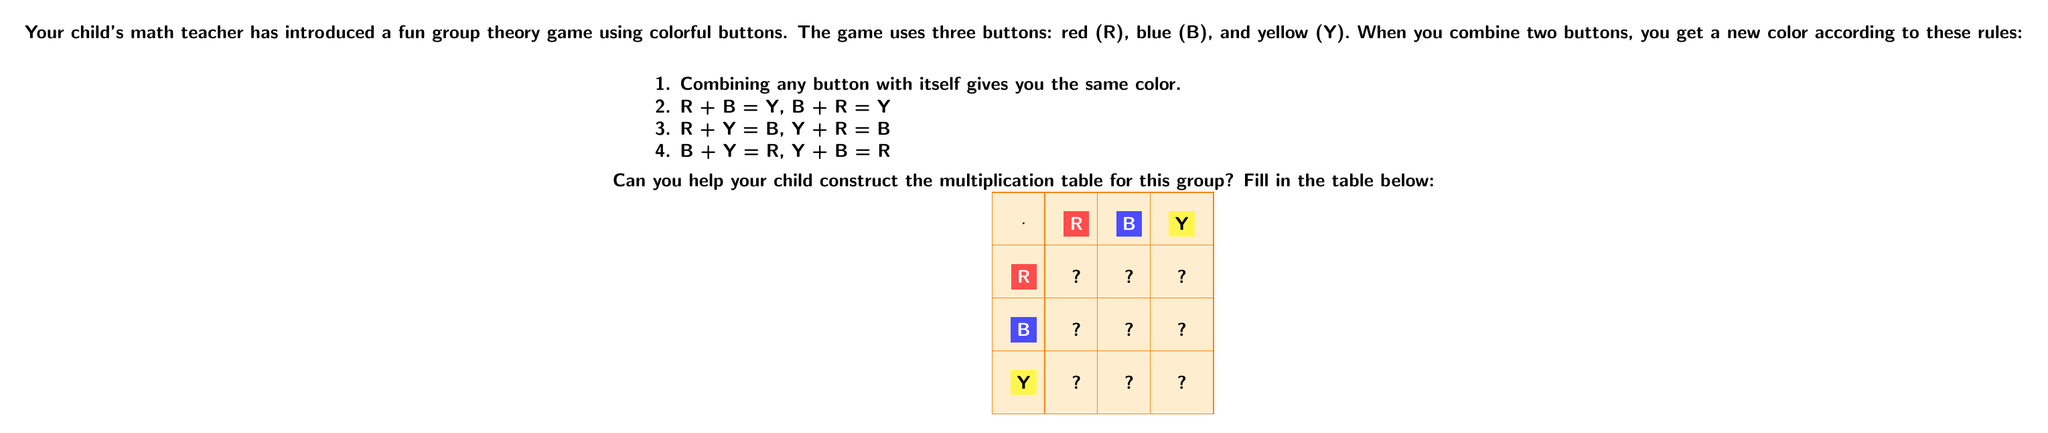Could you help me with this problem? Let's fill in the multiplication table step by step, using the given rules:

1. For the diagonal (combining a color with itself):
   R · R = R
   B · B = B
   Y · Y = Y

2. For R · B and B · R:
   R · B = B · R = Y

3. For R · Y and Y · R:
   R · Y = Y · R = B

4. For B · Y and Y · B:
   B · Y = Y · B = R

Now, let's fill in the table:

[asy]
unitsize(1cm);

string[] labels = {"R", "B", "Y"};
pen[] colors = {red, blue, yellow};
string[][] results = {{"R", "Y", "B"}, {"Y", "B", "R"}, {"B", "R", "Y"}};

for(int i = 0; i < 4; ++i) {
  for(int j = 0; j < 4; ++j) {
    filldraw(box((i,j), (i+1,j+1)), white, black);
    if(i > 0 && j > 0) {
      fill(box((i,j), (i+1,j+1)), colors[find(labels, results[i-1][j-1])]);
      label(results[i-1][j-1], (i+0.5,j+0.5), white);
    } else if(i > 0) {
      fill(box((i,j), (i+1,j+1)), colors[i-1]);
      label(labels[i-1], (i+0.5,j+0.5), white);
    } else if(j > 0) {
      fill(box((i,j), (i+1,j+1)), colors[j-1]);
      label(labels[j-1], (i+0.5,j+0.5), white);
    } else {
      label("$\cdot$", (i+0.5,j+0.5));
    }
  }
}
[/asy]

This group is known as the Klein four-group, often denoted as $V_4$ or $K_4$. It's an abelian group of order 4, meaning that the operation is commutative (a · b = b · a for all elements a and b in the group).
Answer: $$\begin{array}{c|ccc}
\cdot & R & B & Y \\
\hline
R & R & Y & B \\
B & Y & B & R \\
Y & B & R & Y
\end{array}$$ 